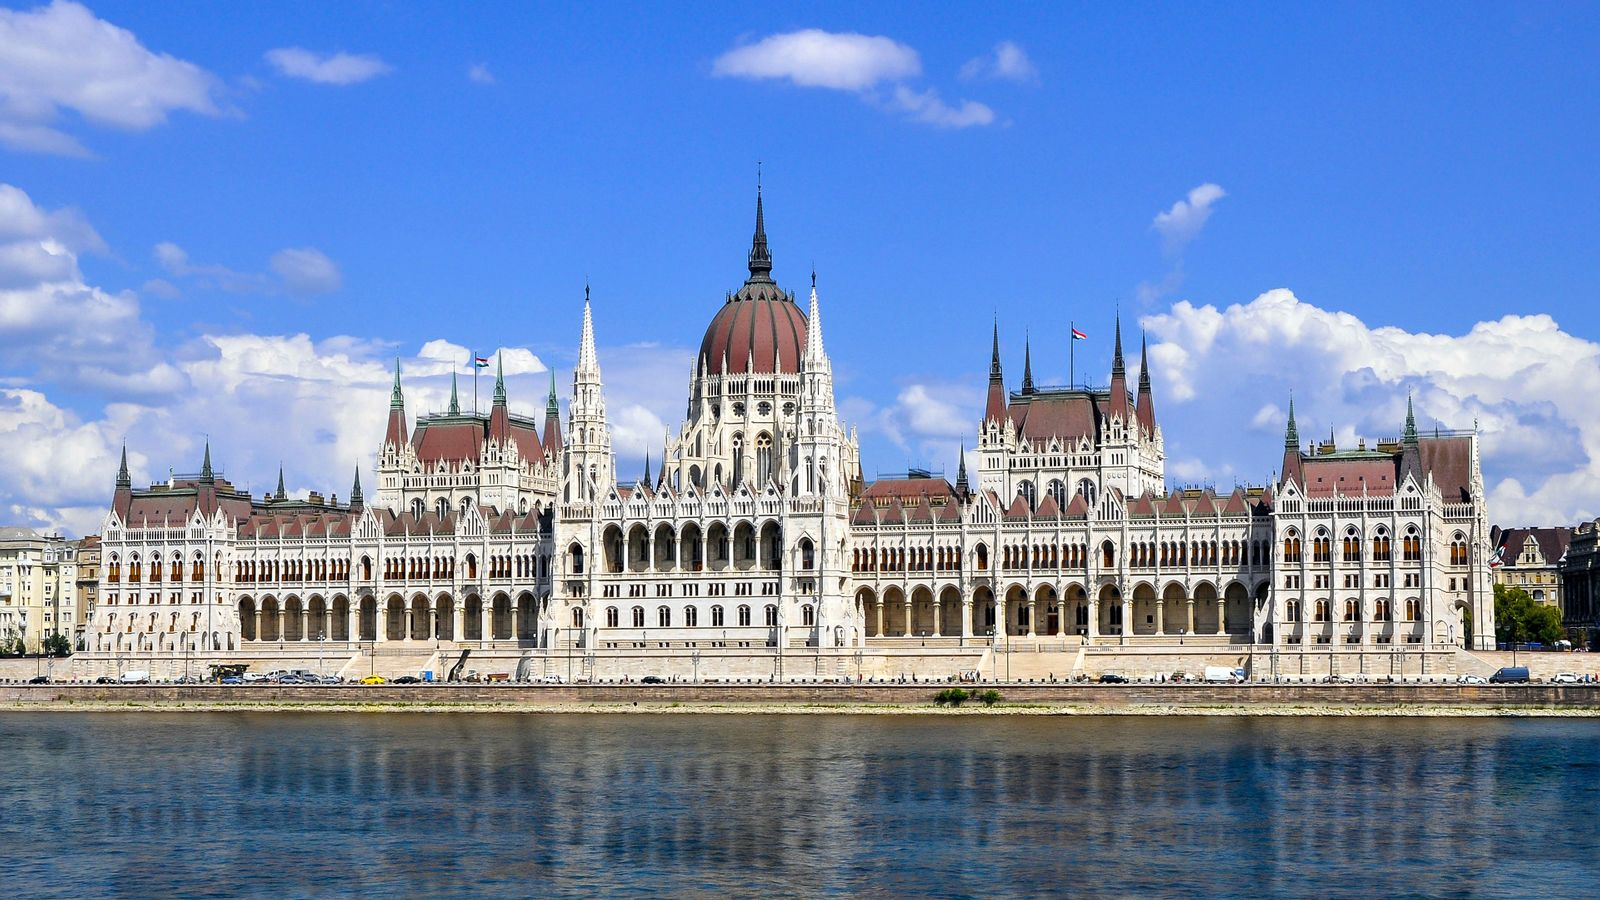Describe the historical significance of this building. The Hungarian Parliament Building, one of the oldest legislative buildings in Europe, holds immense historical significance. It was completed in 1904 to serve as a symbol of Hungary's independence and national identity. The building has witnessed numerous historical events, including political debates, legislative decisions, and state ceremonies. It stands as a testament to the country's rich heritage and architectural prowess. Its design incorporates elements of Gothic Revival and Renaissance Revival styles, signaling the nation's cultural aspirations during its construction period. Over the years, it has become a symbol of both the achievements and the struggles of the Hungarian people, making it not only an architectural landmark but also a monument of national pride. 